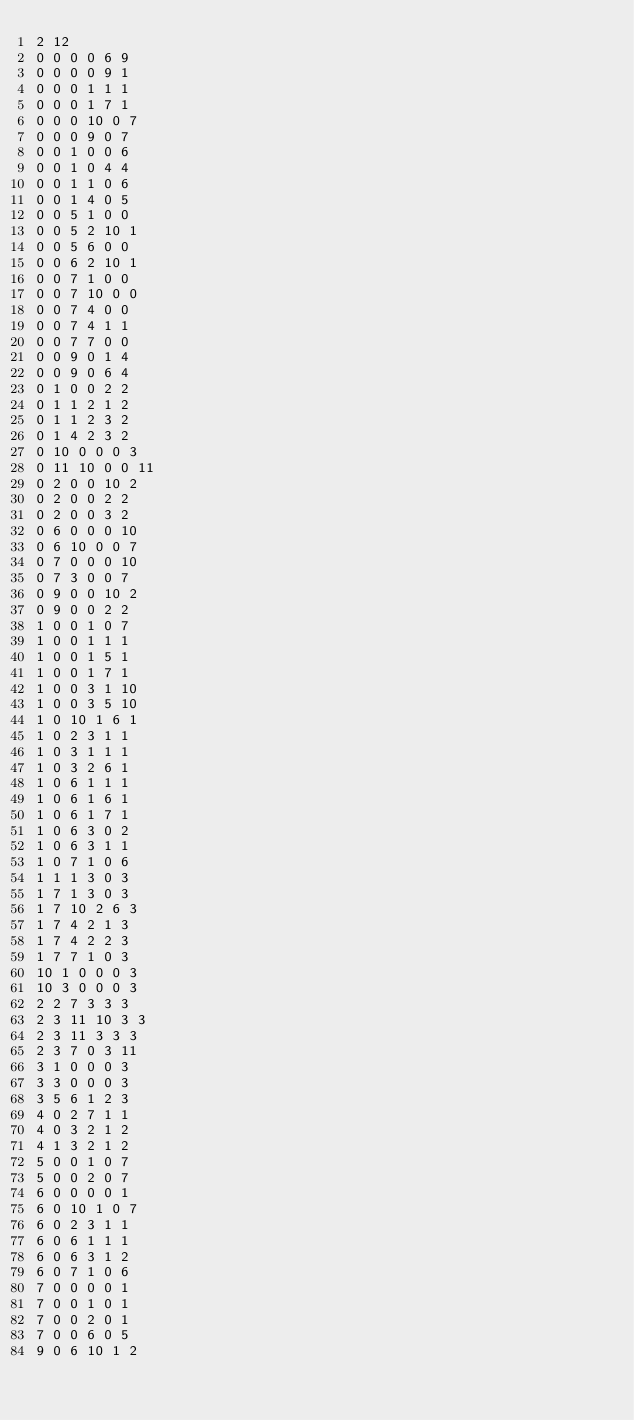<code> <loc_0><loc_0><loc_500><loc_500><_SQL_>2 12
0 0 0 0 6 9
0 0 0 0 9 1
0 0 0 1 1 1
0 0 0 1 7 1
0 0 0 10 0 7
0 0 0 9 0 7
0 0 1 0 0 6
0 0 1 0 4 4
0 0 1 1 0 6
0 0 1 4 0 5
0 0 5 1 0 0
0 0 5 2 10 1
0 0 5 6 0 0
0 0 6 2 10 1
0 0 7 1 0 0
0 0 7 10 0 0
0 0 7 4 0 0
0 0 7 4 1 1
0 0 7 7 0 0
0 0 9 0 1 4
0 0 9 0 6 4
0 1 0 0 2 2
0 1 1 2 1 2
0 1 1 2 3 2
0 1 4 2 3 2
0 10 0 0 0 3
0 11 10 0 0 11
0 2 0 0 10 2
0 2 0 0 2 2
0 2 0 0 3 2
0 6 0 0 0 10
0 6 10 0 0 7
0 7 0 0 0 10
0 7 3 0 0 7
0 9 0 0 10 2
0 9 0 0 2 2
1 0 0 1 0 7
1 0 0 1 1 1
1 0 0 1 5 1
1 0 0 1 7 1
1 0 0 3 1 10
1 0 0 3 5 10
1 0 10 1 6 1
1 0 2 3 1 1
1 0 3 1 1 1
1 0 3 2 6 1
1 0 6 1 1 1
1 0 6 1 6 1
1 0 6 1 7 1
1 0 6 3 0 2
1 0 6 3 1 1
1 0 7 1 0 6
1 1 1 3 0 3
1 7 1 3 0 3
1 7 10 2 6 3
1 7 4 2 1 3
1 7 4 2 2 3
1 7 7 1 0 3
10 1 0 0 0 3
10 3 0 0 0 3
2 2 7 3 3 3
2 3 11 10 3 3
2 3 11 3 3 3
2 3 7 0 3 11
3 1 0 0 0 3
3 3 0 0 0 3
3 5 6 1 2 3
4 0 2 7 1 1
4 0 3 2 1 2
4 1 3 2 1 2
5 0 0 1 0 7
5 0 0 2 0 7
6 0 0 0 0 1
6 0 10 1 0 7
6 0 2 3 1 1
6 0 6 1 1 1
6 0 6 3 1 2
6 0 7 1 0 6
7 0 0 0 0 1
7 0 0 1 0 1
7 0 0 2 0 1
7 0 0 6 0 5
9 0 6 10 1 2
</code> 